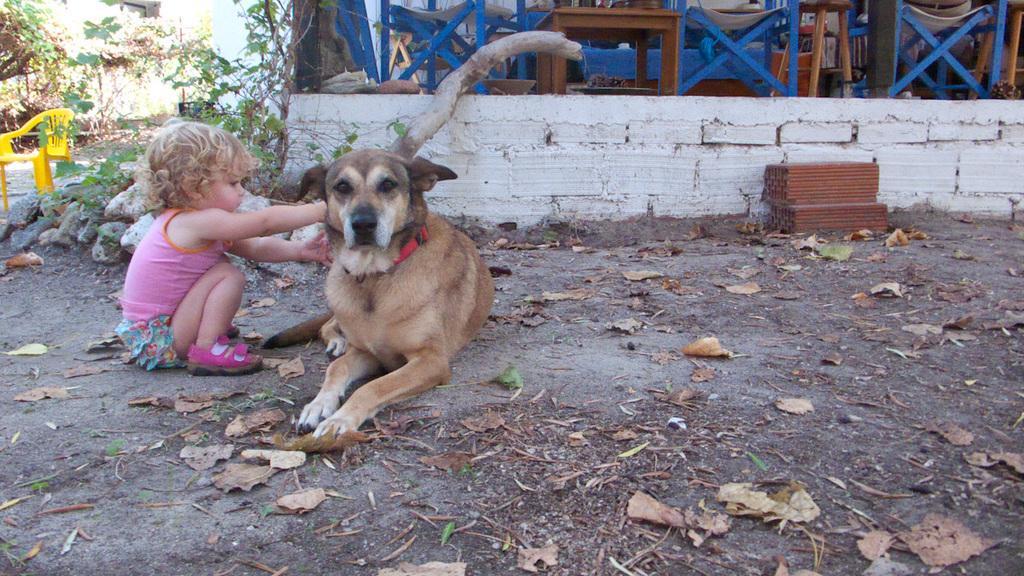How would you summarize this image in a sentence or two? In this image, In the middle there is a dog which is in brown color, In the left there is a child sitting on the ground, In the background there is a wall which is in white color, There are some tables which are in blue color, In the left side there is a chair which is in yellow color. 